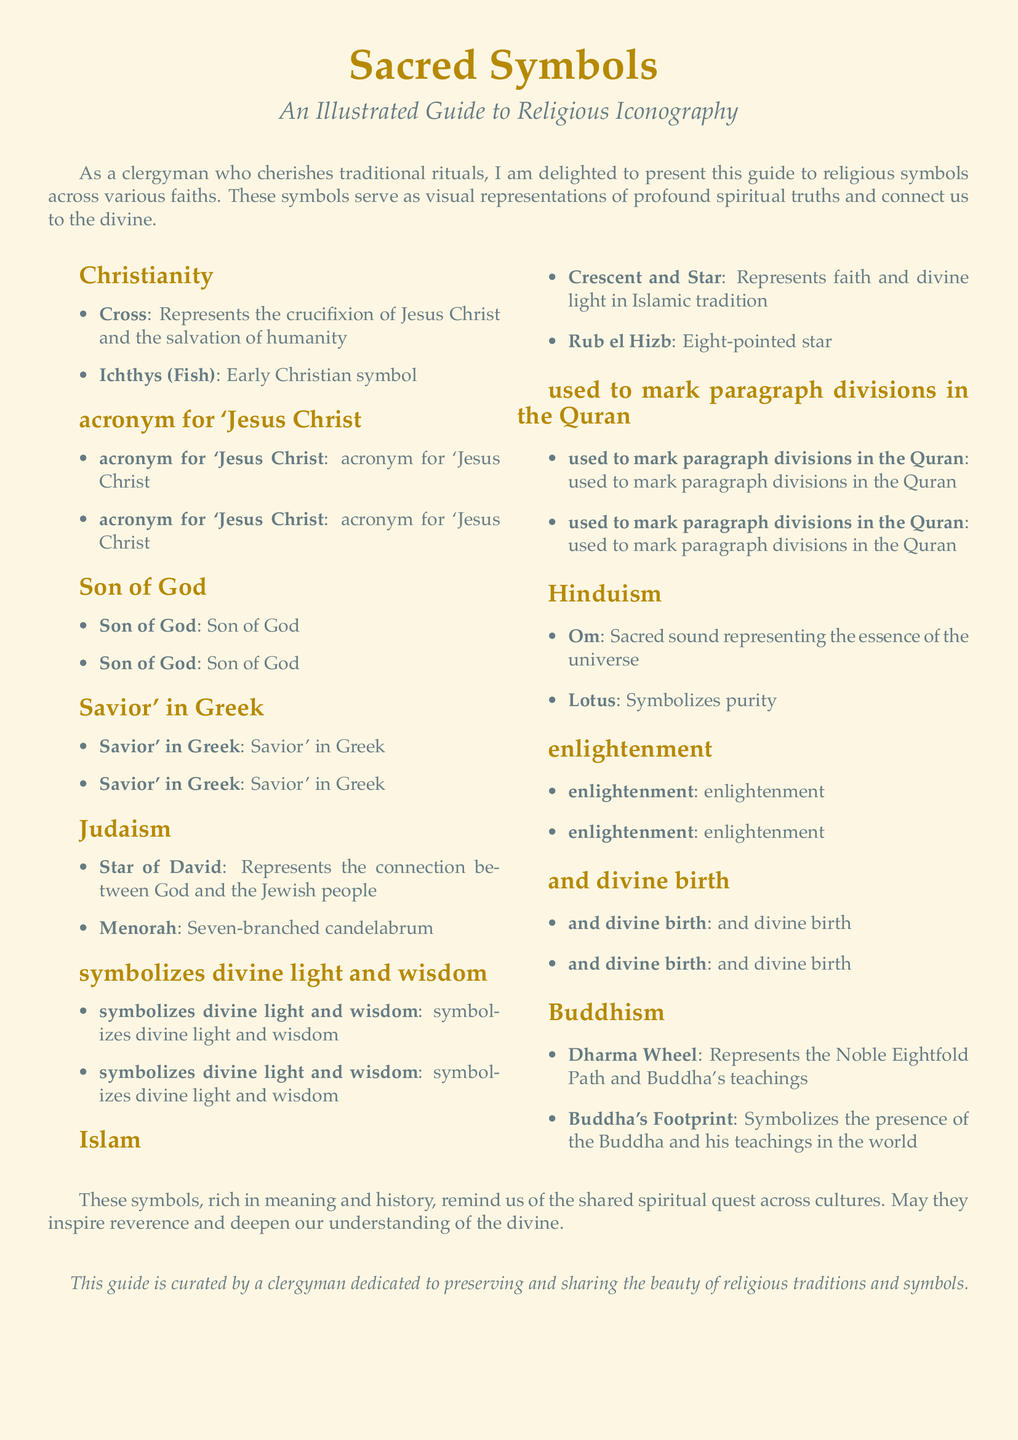What is represented by the Cross? The Cross represents the crucifixion of Jesus Christ and the salvation of humanity.
Answer: Crucifixion of Jesus Christ and salvation of humanity What does the Star of David symbolize? The Star of David symbolizes the connection between God and the Jewish people.
Answer: Connection between God and the Jewish people How many branches does the Menorah have? The description of the Menorah states it has seven branches.
Answer: Seven What is the meaning of the Om symbol? The Om symbol represents the sacred sound of the essence of the universe.
Answer: Sacred sound representing the essence of the universe Which symbol is associated with Buddhism? The Dharma Wheel and Buddha's Footprint are the symbols of Buddhism listed in the document.
Answer: Dharma Wheel, Buddha's Footprint What does the Crescent and Star represent in Islam? The Crescent and Star represents faith and divine light in Islamic tradition.
Answer: Faith and divine light in Islamic tradition Which religion is associated with the symbol of the Lotus? The Lotus is associated with Hinduism, as mentioned in the document.
Answer: Hinduism Which symbol is an early Christian acronym? The Ichthys (Fish) is referred to as early Christian symbol and acronym.
Answer: Ichthys (Fish) What thematic understanding does the guide aim to inspire? The guide aims to inspire reverence and deepen understanding of the divine.
Answer: Reverence and understanding of the divine 